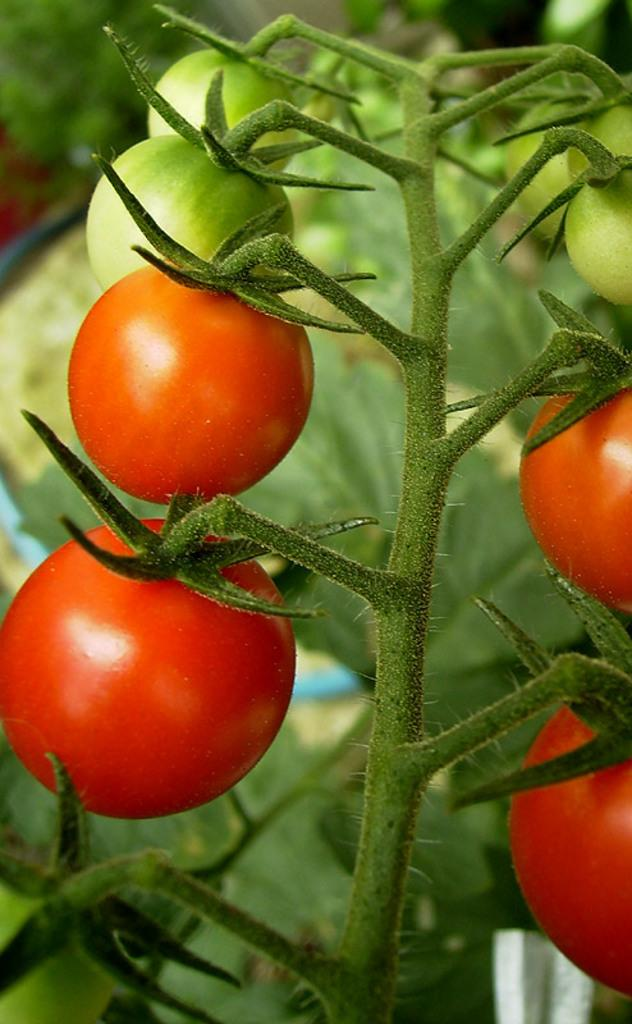What is the main object in the image? There is a stem in the image. What is attached to the stem? The stem has tomatoes on it. Can you describe the background of the image? The background of the image is blurry. What type of humor can be observed in the tomatoes in the image? There is no humor present in the tomatoes in the image; they are simply fruits attached to a stem. 